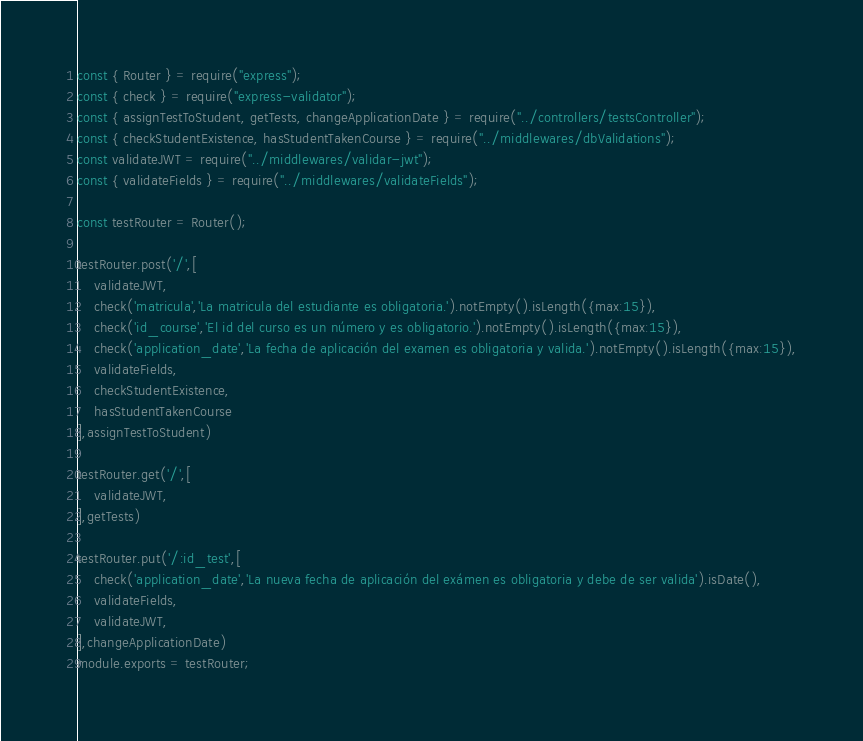<code> <loc_0><loc_0><loc_500><loc_500><_JavaScript_>const { Router } = require("express");
const { check } = require("express-validator");
const { assignTestToStudent, getTests, changeApplicationDate } = require("../controllers/testsController");
const { checkStudentExistence, hasStudentTakenCourse } = require("../middlewares/dbValidations");
const validateJWT = require("../middlewares/validar-jwt");
const { validateFields } = require("../middlewares/validateFields");

const testRouter = Router();

testRouter.post('/',[
    validateJWT,
    check('matricula','La matricula del estudiante es obligatoria.').notEmpty().isLength({max:15}),
    check('id_course','El id del curso es un número y es obligatorio.').notEmpty().isLength({max:15}),
    check('application_date','La fecha de aplicación del examen es obligatoria y valida.').notEmpty().isLength({max:15}),
    validateFields,
    checkStudentExistence,
    hasStudentTakenCourse
],assignTestToStudent)

testRouter.get('/',[
    validateJWT,
],getTests)

testRouter.put('/:id_test',[
    check('application_date','La nueva fecha de aplicación del exámen es obligatoria y debe de ser valida').isDate(),
    validateFields,
    validateJWT,
],changeApplicationDate)
module.exports = testRouter;
</code> 